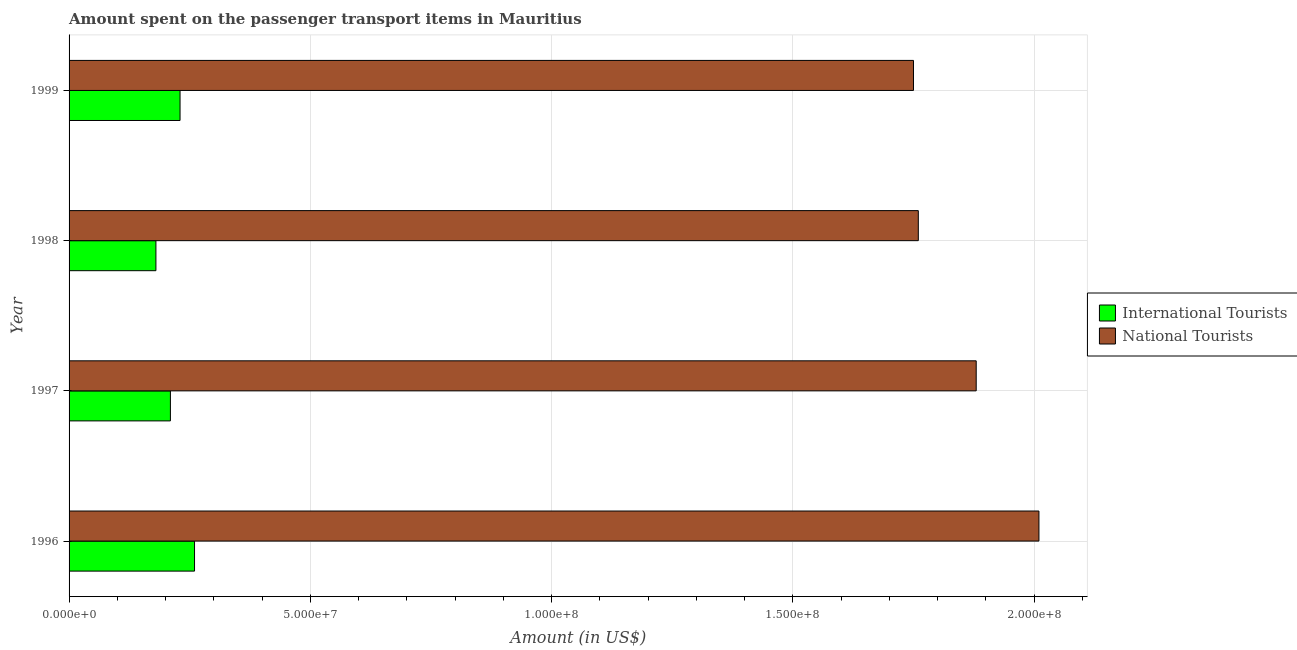How many different coloured bars are there?
Provide a succinct answer. 2. How many groups of bars are there?
Your answer should be compact. 4. How many bars are there on the 4th tick from the bottom?
Give a very brief answer. 2. In how many cases, is the number of bars for a given year not equal to the number of legend labels?
Keep it short and to the point. 0. What is the amount spent on transport items of international tourists in 1998?
Your answer should be very brief. 1.80e+07. Across all years, what is the maximum amount spent on transport items of international tourists?
Your response must be concise. 2.60e+07. Across all years, what is the minimum amount spent on transport items of international tourists?
Ensure brevity in your answer.  1.80e+07. In which year was the amount spent on transport items of international tourists maximum?
Your answer should be compact. 1996. In which year was the amount spent on transport items of national tourists minimum?
Make the answer very short. 1999. What is the total amount spent on transport items of national tourists in the graph?
Give a very brief answer. 7.40e+08. What is the difference between the amount spent on transport items of national tourists in 1997 and that in 1998?
Your response must be concise. 1.20e+07. What is the difference between the amount spent on transport items of international tourists in 1999 and the amount spent on transport items of national tourists in 1998?
Offer a very short reply. -1.53e+08. What is the average amount spent on transport items of national tourists per year?
Provide a succinct answer. 1.85e+08. In the year 1998, what is the difference between the amount spent on transport items of international tourists and amount spent on transport items of national tourists?
Keep it short and to the point. -1.58e+08. In how many years, is the amount spent on transport items of national tourists greater than 200000000 US$?
Provide a succinct answer. 1. What is the ratio of the amount spent on transport items of national tourists in 1996 to that in 1998?
Your answer should be compact. 1.14. Is the difference between the amount spent on transport items of international tourists in 1996 and 1997 greater than the difference between the amount spent on transport items of national tourists in 1996 and 1997?
Keep it short and to the point. No. What is the difference between the highest and the second highest amount spent on transport items of national tourists?
Provide a short and direct response. 1.30e+07. What is the difference between the highest and the lowest amount spent on transport items of national tourists?
Your answer should be compact. 2.60e+07. In how many years, is the amount spent on transport items of international tourists greater than the average amount spent on transport items of international tourists taken over all years?
Make the answer very short. 2. Is the sum of the amount spent on transport items of national tourists in 1997 and 1999 greater than the maximum amount spent on transport items of international tourists across all years?
Make the answer very short. Yes. What does the 2nd bar from the top in 1998 represents?
Offer a terse response. International Tourists. What does the 2nd bar from the bottom in 1997 represents?
Your answer should be compact. National Tourists. How many years are there in the graph?
Offer a very short reply. 4. What is the difference between two consecutive major ticks on the X-axis?
Offer a very short reply. 5.00e+07. Are the values on the major ticks of X-axis written in scientific E-notation?
Provide a short and direct response. Yes. Does the graph contain grids?
Make the answer very short. Yes. How many legend labels are there?
Your answer should be compact. 2. What is the title of the graph?
Give a very brief answer. Amount spent on the passenger transport items in Mauritius. What is the label or title of the X-axis?
Keep it short and to the point. Amount (in US$). What is the label or title of the Y-axis?
Offer a very short reply. Year. What is the Amount (in US$) of International Tourists in 1996?
Your answer should be very brief. 2.60e+07. What is the Amount (in US$) in National Tourists in 1996?
Make the answer very short. 2.01e+08. What is the Amount (in US$) in International Tourists in 1997?
Offer a terse response. 2.10e+07. What is the Amount (in US$) in National Tourists in 1997?
Make the answer very short. 1.88e+08. What is the Amount (in US$) of International Tourists in 1998?
Ensure brevity in your answer.  1.80e+07. What is the Amount (in US$) in National Tourists in 1998?
Offer a terse response. 1.76e+08. What is the Amount (in US$) of International Tourists in 1999?
Your answer should be compact. 2.30e+07. What is the Amount (in US$) of National Tourists in 1999?
Provide a succinct answer. 1.75e+08. Across all years, what is the maximum Amount (in US$) in International Tourists?
Offer a very short reply. 2.60e+07. Across all years, what is the maximum Amount (in US$) of National Tourists?
Your answer should be very brief. 2.01e+08. Across all years, what is the minimum Amount (in US$) in International Tourists?
Your response must be concise. 1.80e+07. Across all years, what is the minimum Amount (in US$) in National Tourists?
Your response must be concise. 1.75e+08. What is the total Amount (in US$) of International Tourists in the graph?
Ensure brevity in your answer.  8.80e+07. What is the total Amount (in US$) of National Tourists in the graph?
Provide a succinct answer. 7.40e+08. What is the difference between the Amount (in US$) of International Tourists in 1996 and that in 1997?
Your answer should be very brief. 5.00e+06. What is the difference between the Amount (in US$) in National Tourists in 1996 and that in 1997?
Give a very brief answer. 1.30e+07. What is the difference between the Amount (in US$) in National Tourists in 1996 and that in 1998?
Provide a short and direct response. 2.50e+07. What is the difference between the Amount (in US$) in National Tourists in 1996 and that in 1999?
Your response must be concise. 2.60e+07. What is the difference between the Amount (in US$) in International Tourists in 1997 and that in 1998?
Ensure brevity in your answer.  3.00e+06. What is the difference between the Amount (in US$) in National Tourists in 1997 and that in 1999?
Provide a succinct answer. 1.30e+07. What is the difference between the Amount (in US$) in International Tourists in 1998 and that in 1999?
Your answer should be compact. -5.00e+06. What is the difference between the Amount (in US$) of International Tourists in 1996 and the Amount (in US$) of National Tourists in 1997?
Your answer should be very brief. -1.62e+08. What is the difference between the Amount (in US$) of International Tourists in 1996 and the Amount (in US$) of National Tourists in 1998?
Your answer should be very brief. -1.50e+08. What is the difference between the Amount (in US$) in International Tourists in 1996 and the Amount (in US$) in National Tourists in 1999?
Ensure brevity in your answer.  -1.49e+08. What is the difference between the Amount (in US$) of International Tourists in 1997 and the Amount (in US$) of National Tourists in 1998?
Give a very brief answer. -1.55e+08. What is the difference between the Amount (in US$) in International Tourists in 1997 and the Amount (in US$) in National Tourists in 1999?
Your answer should be very brief. -1.54e+08. What is the difference between the Amount (in US$) in International Tourists in 1998 and the Amount (in US$) in National Tourists in 1999?
Provide a short and direct response. -1.57e+08. What is the average Amount (in US$) in International Tourists per year?
Ensure brevity in your answer.  2.20e+07. What is the average Amount (in US$) in National Tourists per year?
Provide a succinct answer. 1.85e+08. In the year 1996, what is the difference between the Amount (in US$) of International Tourists and Amount (in US$) of National Tourists?
Make the answer very short. -1.75e+08. In the year 1997, what is the difference between the Amount (in US$) in International Tourists and Amount (in US$) in National Tourists?
Offer a very short reply. -1.67e+08. In the year 1998, what is the difference between the Amount (in US$) in International Tourists and Amount (in US$) in National Tourists?
Your answer should be very brief. -1.58e+08. In the year 1999, what is the difference between the Amount (in US$) in International Tourists and Amount (in US$) in National Tourists?
Give a very brief answer. -1.52e+08. What is the ratio of the Amount (in US$) of International Tourists in 1996 to that in 1997?
Provide a short and direct response. 1.24. What is the ratio of the Amount (in US$) in National Tourists in 1996 to that in 1997?
Offer a terse response. 1.07. What is the ratio of the Amount (in US$) of International Tourists in 1996 to that in 1998?
Ensure brevity in your answer.  1.44. What is the ratio of the Amount (in US$) of National Tourists in 1996 to that in 1998?
Offer a very short reply. 1.14. What is the ratio of the Amount (in US$) in International Tourists in 1996 to that in 1999?
Your response must be concise. 1.13. What is the ratio of the Amount (in US$) in National Tourists in 1996 to that in 1999?
Your answer should be compact. 1.15. What is the ratio of the Amount (in US$) in National Tourists in 1997 to that in 1998?
Your answer should be very brief. 1.07. What is the ratio of the Amount (in US$) in National Tourists in 1997 to that in 1999?
Your response must be concise. 1.07. What is the ratio of the Amount (in US$) of International Tourists in 1998 to that in 1999?
Your answer should be compact. 0.78. What is the difference between the highest and the second highest Amount (in US$) of National Tourists?
Offer a very short reply. 1.30e+07. What is the difference between the highest and the lowest Amount (in US$) of International Tourists?
Give a very brief answer. 8.00e+06. What is the difference between the highest and the lowest Amount (in US$) in National Tourists?
Keep it short and to the point. 2.60e+07. 